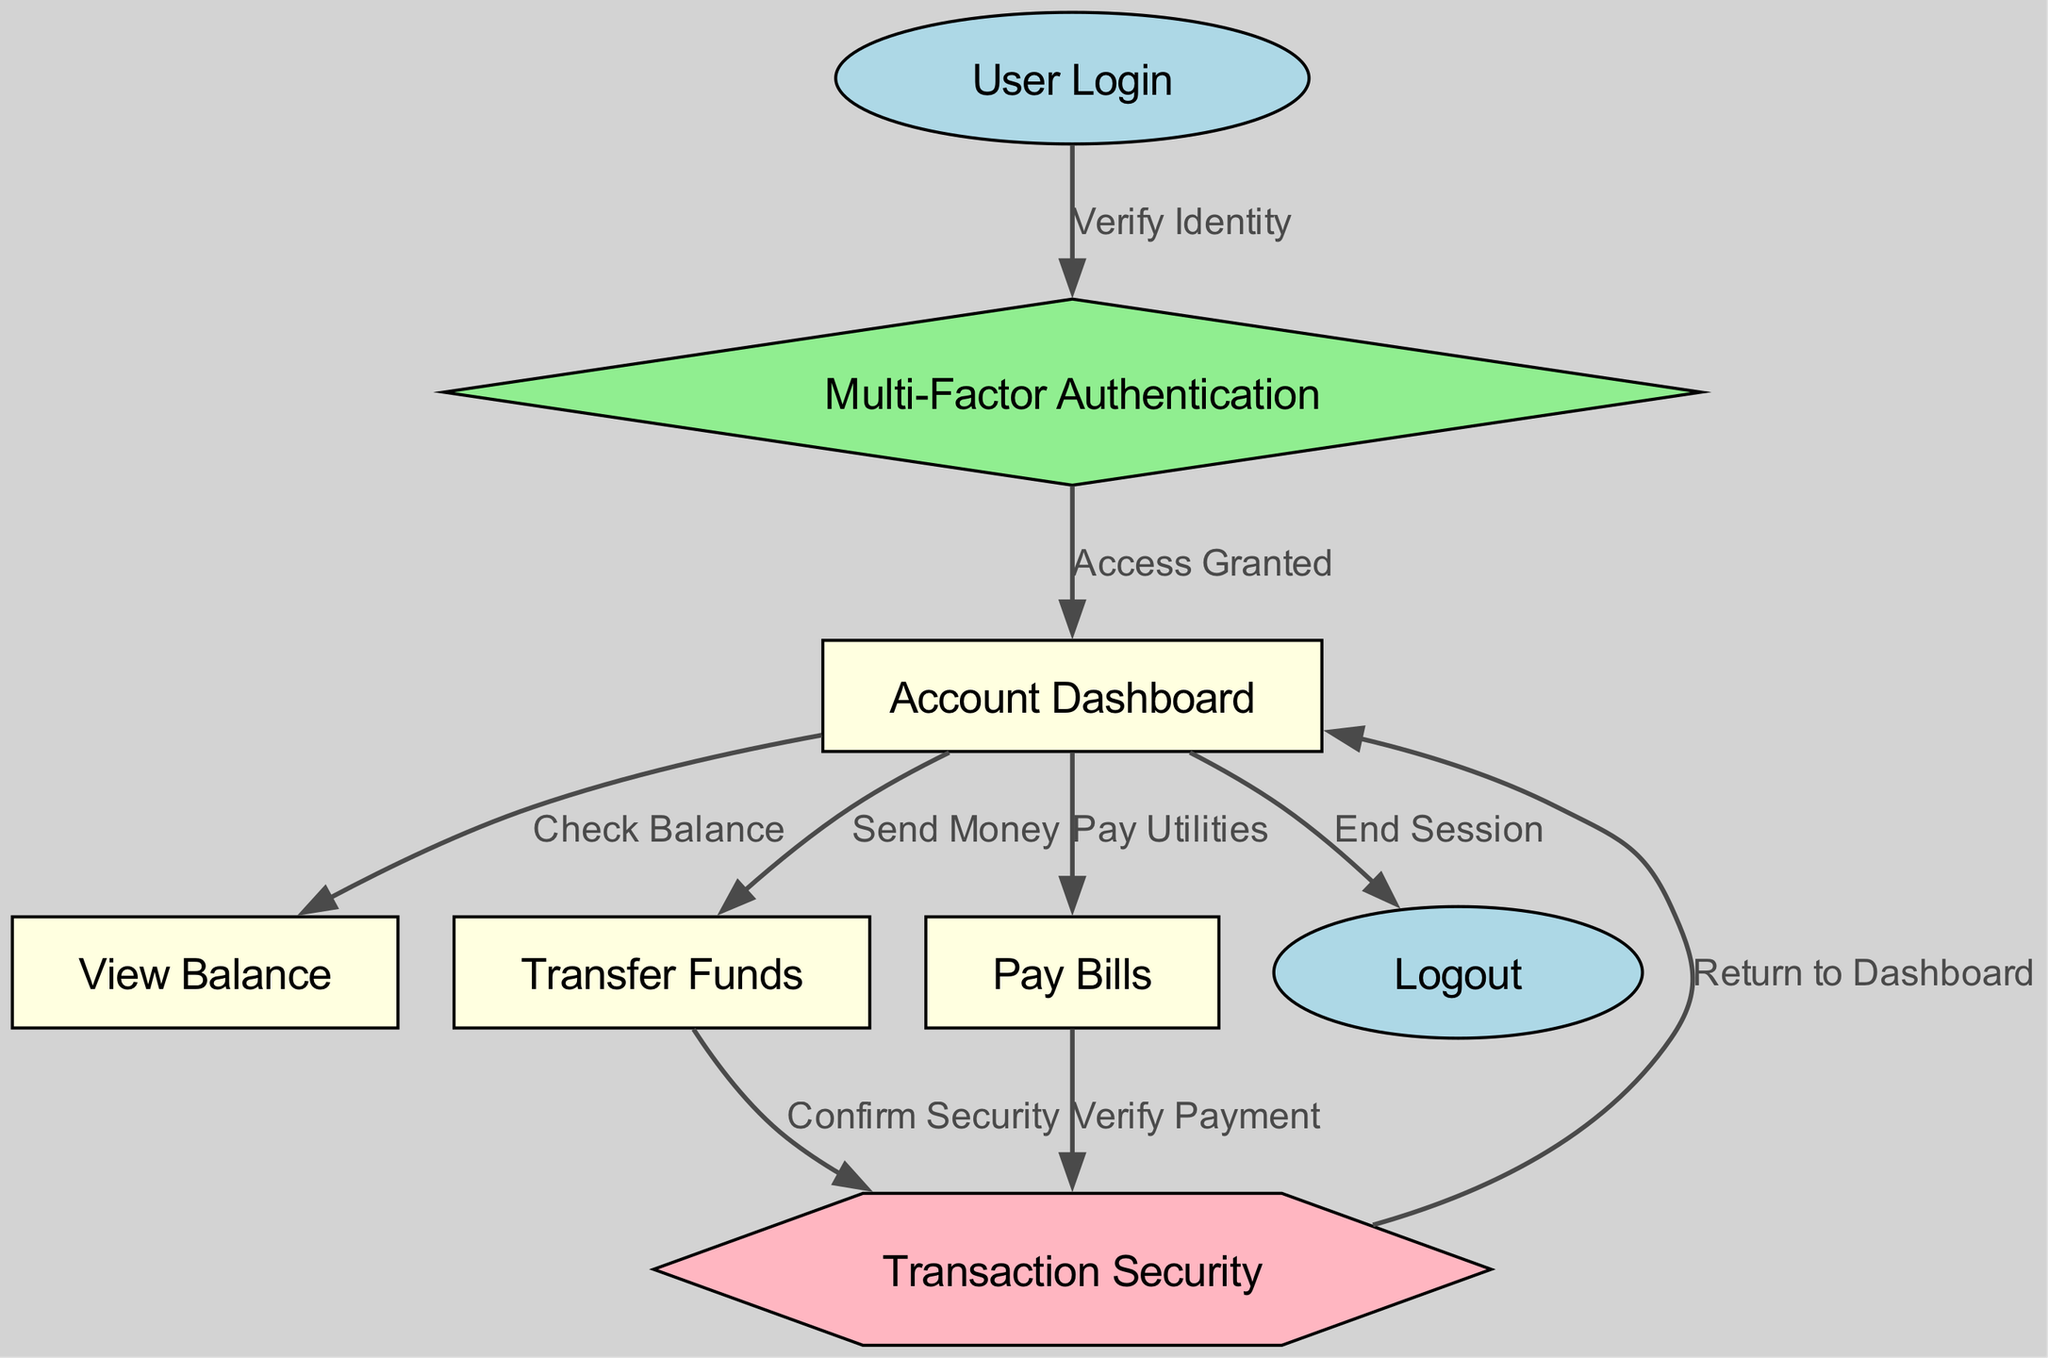What is the first step in the online banking process? The first step indicated in the diagram is "User Login," which is represented as the initial node before any other actions can occur.
Answer: User Login How many nodes are there in the diagram? By counting the nodes listed in the data section, we can see that there are a total of 8 nodes, each representing a different stage in the online banking process.
Answer: 8 What action is taken after Multi-Factor Authentication? Following the "Multi-Factor Authentication," the next action is "Account Dashboard," indicating successful verification and access to the account.
Answer: Account Dashboard What shape represents Transaction Security in the diagram? The "Transaction Security" node is represented as a hexagon, a unique shape that distinguishes it from other types of nodes in the diagram.
Answer: Hexagon How does a user check their balance according to the diagram? To check their balance, a user moves from the "Account Dashboard" to the "View Balance" node, which is a key action that can be initiated from the dashboard.
Answer: View Balance What is the final action in the online banking process depicted in the diagram? The final action shown in the diagram is "Logout," indicating the end of the session and the completion of the online banking process.
Answer: Logout Which two actions require transaction security confirmation? The actions that require transaction security confirmation are "Transfer Funds" and "Pay Bills," as both these actions lead to the "Transaction Security" node for verification.
Answer: Transfer Funds and Pay Bills What can a user do from the Account Dashboard? From the "Account Dashboard," a user can perform three main actions: check their balance, transfer funds, and pay bills, as indicated by the connections from the dashboard to these subsequent nodes.
Answer: Check Balance, Transfer Funds, Pay Bills 